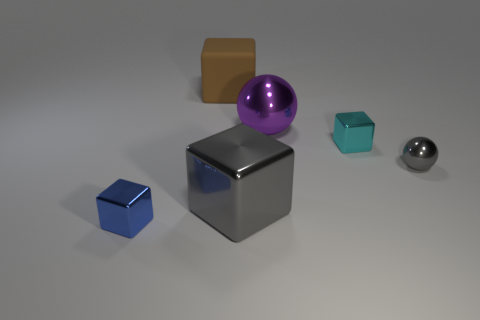Add 1 blue matte balls. How many objects exist? 7 Subtract all spheres. How many objects are left? 4 Subtract all brown rubber objects. Subtract all big shiny cubes. How many objects are left? 4 Add 6 purple shiny objects. How many purple shiny objects are left? 7 Add 3 yellow shiny cubes. How many yellow shiny cubes exist? 3 Subtract 1 blue blocks. How many objects are left? 5 